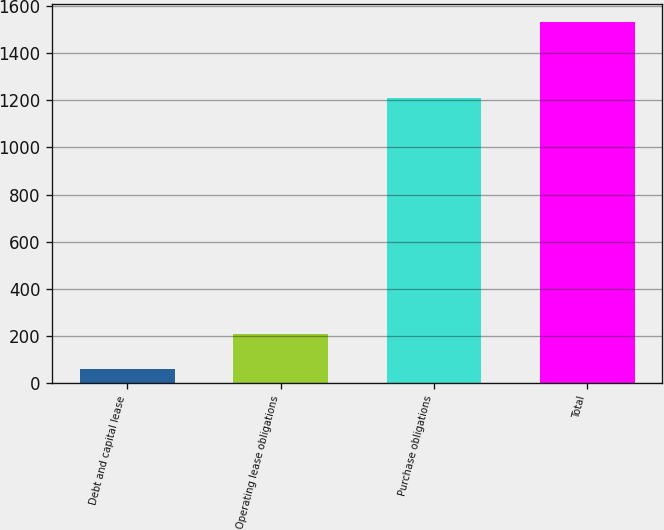<chart> <loc_0><loc_0><loc_500><loc_500><bar_chart><fcel>Debt and capital lease<fcel>Operating lease obligations<fcel>Purchase obligations<fcel>Total<nl><fcel>60<fcel>207.1<fcel>1209<fcel>1531<nl></chart> 